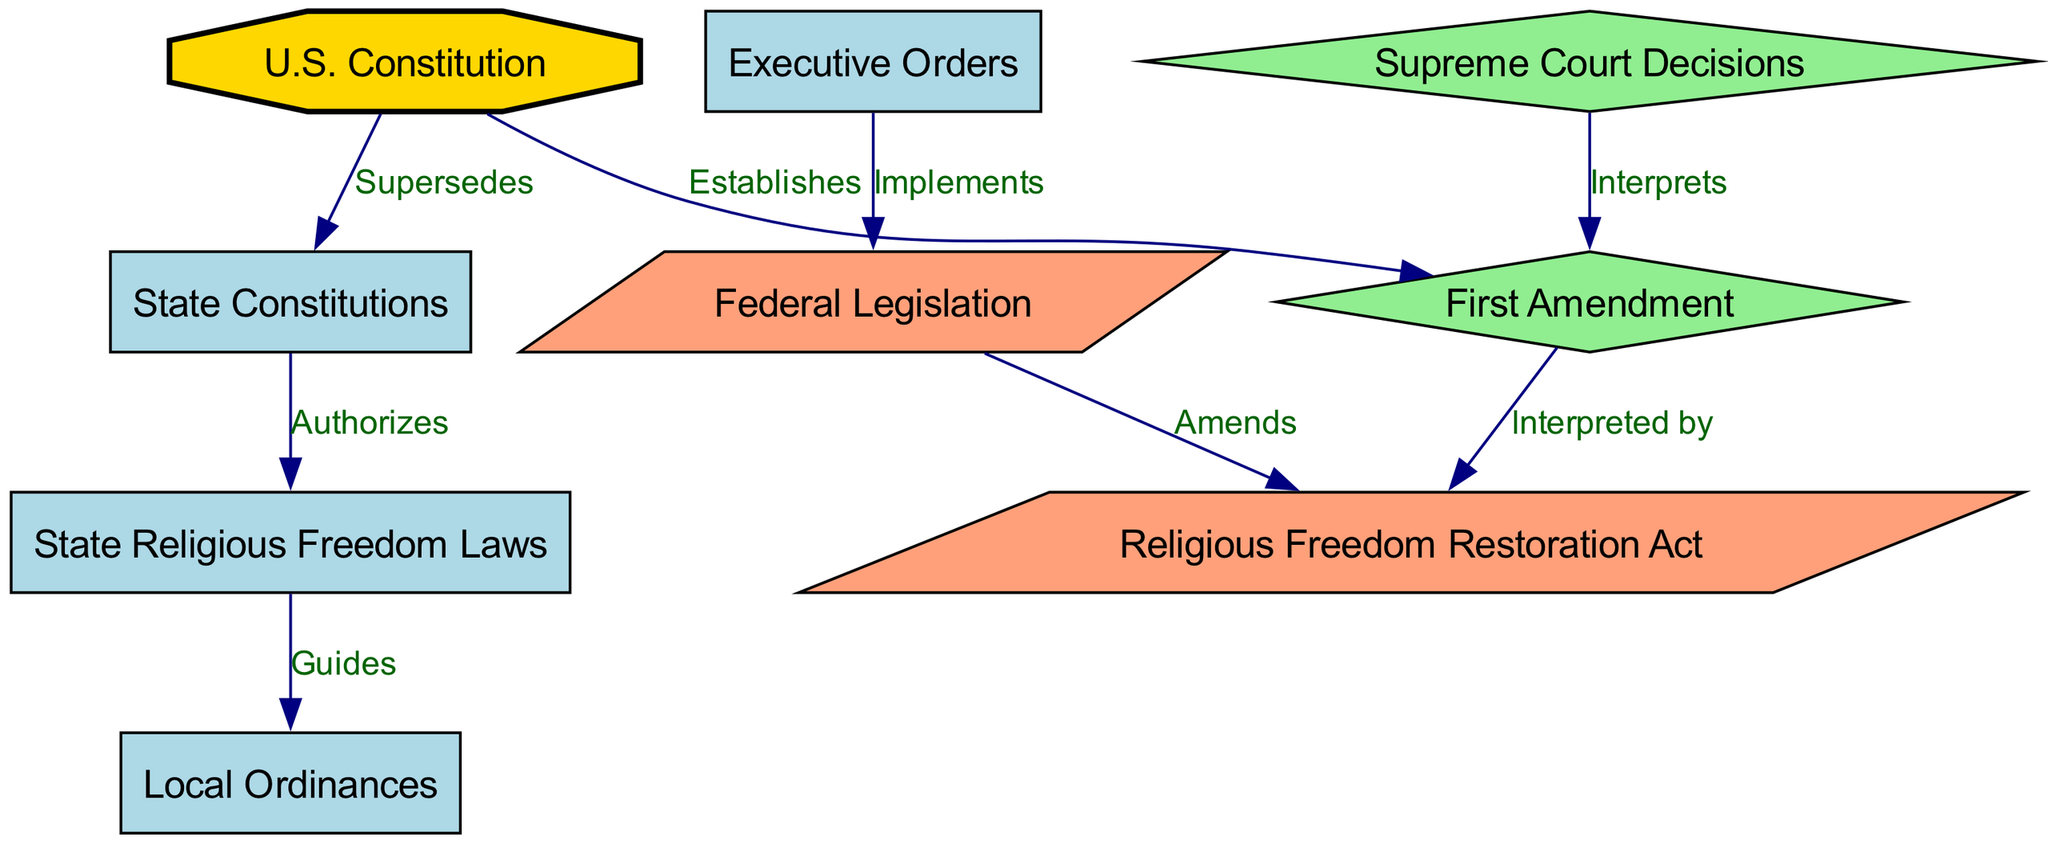What node establishes the First Amendment? The U.S. Constitution is the foundational document that establishes the First Amendment as part of its text. The diagram clearly indicates this relationship through a directed edge labeled "Establishes" from the U.S. Constitution to the First Amendment.
Answer: U.S. Constitution Which node is authorized by State Constitutions? The State Religious Freedom Laws are authorized by State Constitutions, as indicated by the directed edge labeled "Authorizes" connecting these two nodes in the diagram.
Answer: State Religious Freedom Laws How many nodes are present in the diagram? The diagram contains a total of nine distinct nodes representing various components of the constitutional hierarchy regarding religious freedom laws. By counting each unique node in the data, we can determine the total number.
Answer: Nine What interprets the First Amendment according to the diagram? The Supreme Court Decisions are shown to interpret the First Amendment, as demonstrated by the directed edge labeled "Interprets" that leads from the Supreme Court Decisions to the First Amendment.
Answer: Supreme Court Decisions What are Local Ordinances guided by? Local Ordinances are guided by State Religious Freedom Laws, as represented by the directed edge labeled "Guides" moving from State Religious Freedom Laws to Local Ordinances.
Answer: State Religious Freedom Laws Which law does Federal Legislation amend? The Federal Legislation is indicated to amend the Religious Freedom Restoration Act, represented by the directed edge labeled "Amends" between these two nodes in the diagram.
Answer: Religious Freedom Restoration Act How does Executive Orders impact Federal Legislation? Executive Orders implement Federal Legislation, as shown by the directed edge labeled "Implements" moving from Executive Orders to Federal Legislation in the diagram.
Answer: Implements What legal document supersedes State Constitutions? The U.S. Constitution supersedes State Constitutions, as indicated by the directed edge labeled "Supersedes" flowing from the U.S. Constitution to State Constitutions.
Answer: U.S. Constitution 